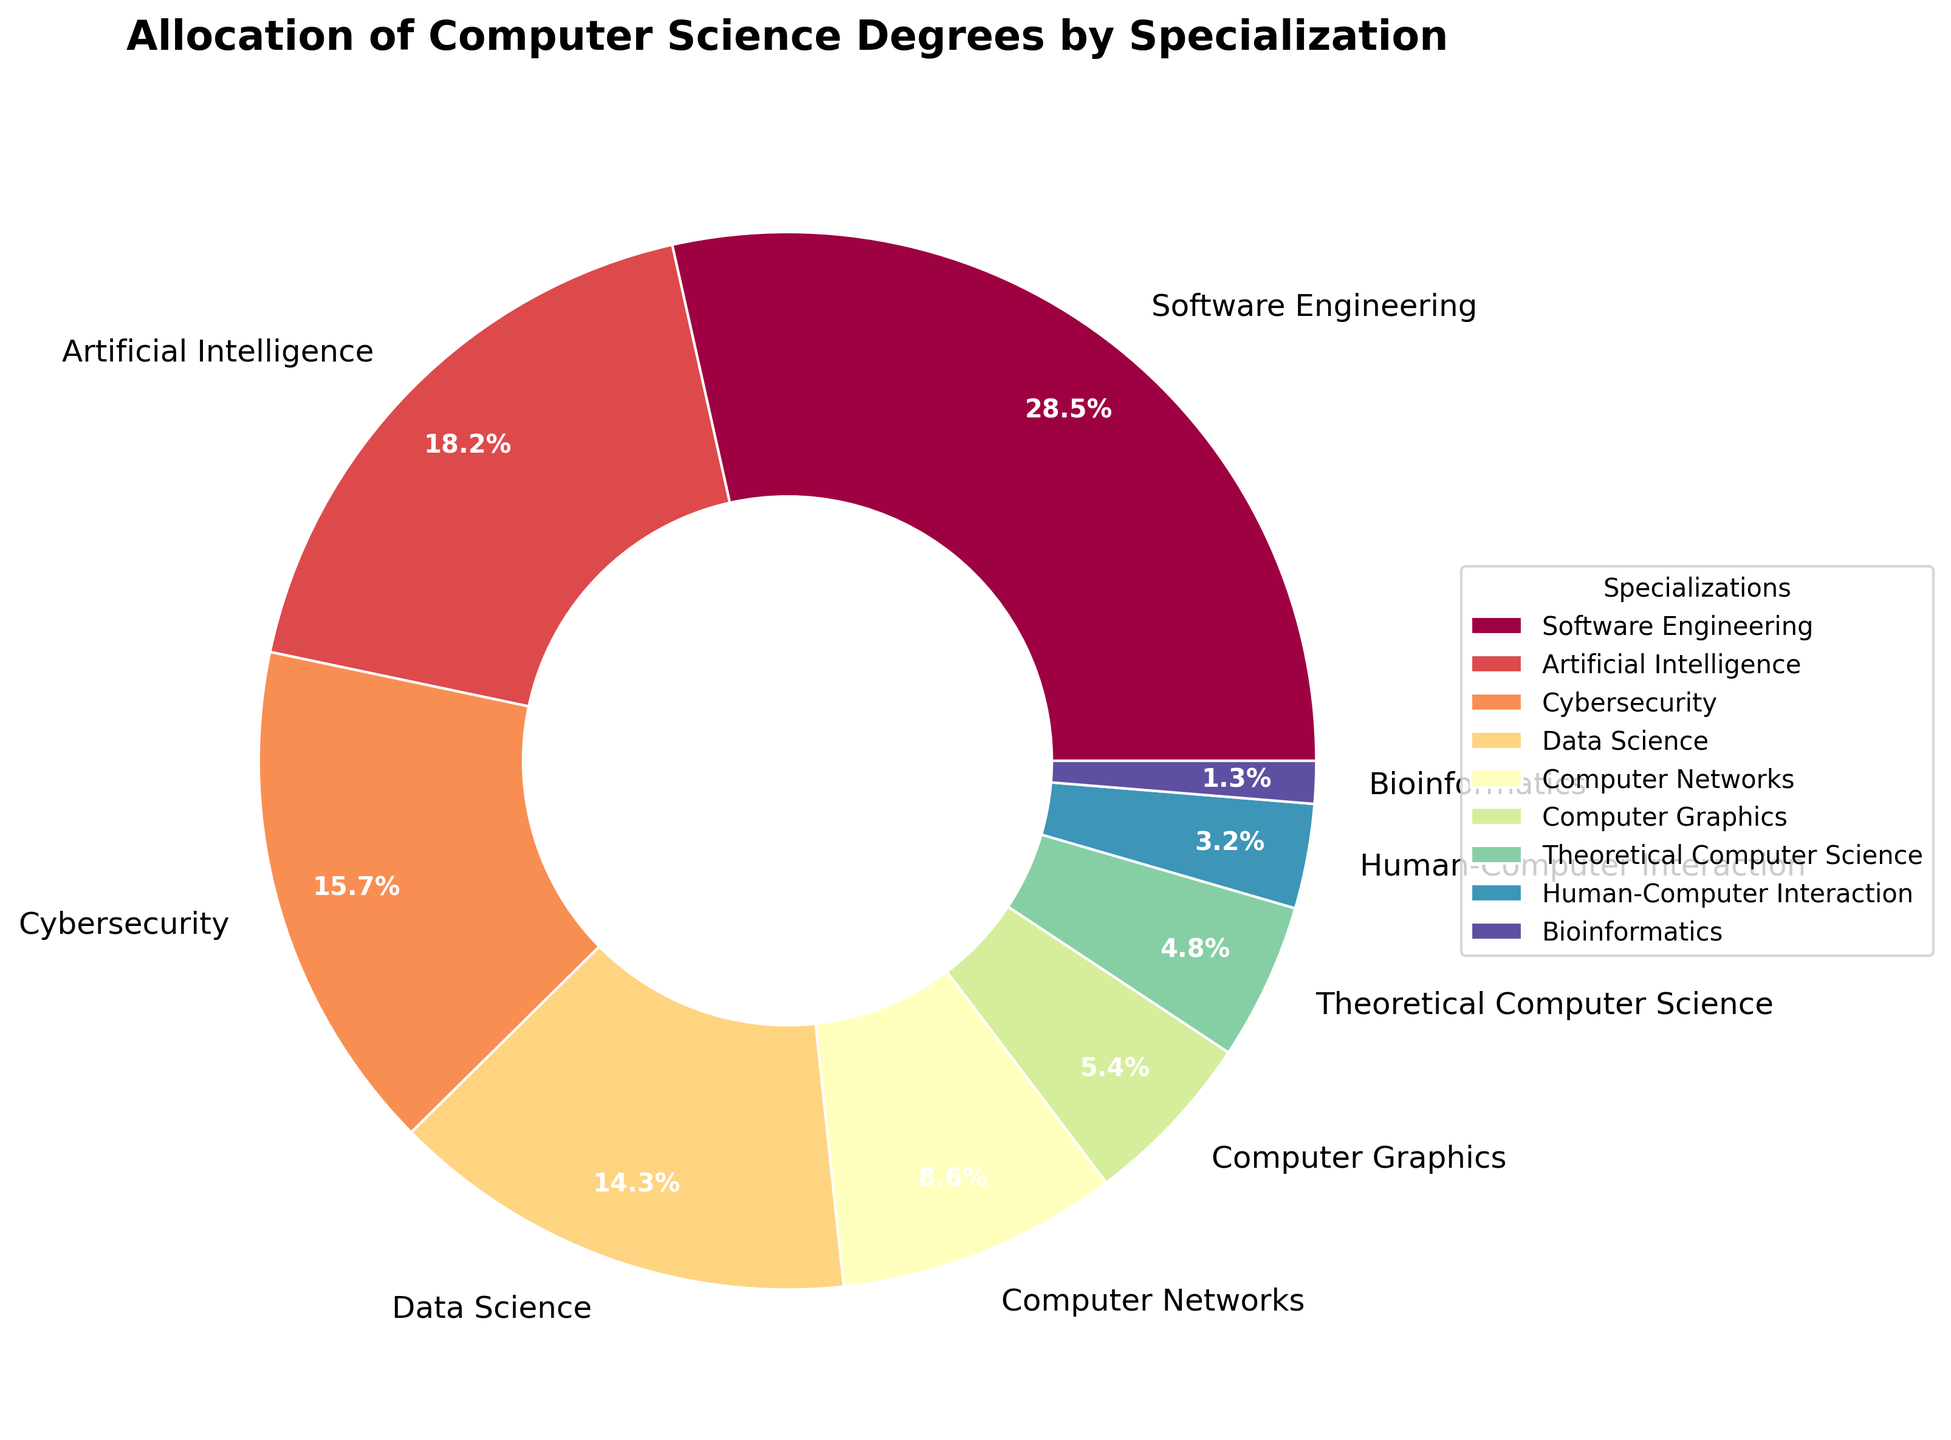Which specialization has the highest percentage of computer science degrees? By observing the sizes of the wedges and reading their labels, we see that Software Engineering has the largest wedge with 28.5%.
Answer: Software Engineering Which specialization has the smallest percentage of computer science degrees? By observing the sizes of the wedges and reading their labels, we see that Bioinformatics has the smallest wedge with 1.3%.
Answer: Bioinformatics What is the combined percentage of degrees in Artificial Intelligence and Cybersecurity? Adding the percentages for Artificial Intelligence (18.2%) and Cybersecurity (15.7%) gives us 18.2% + 15.7% = 33.9%.
Answer: 33.9% How much larger is the percentage of degrees in Software Engineering compared to Data Science? Subtract the percentage of Data Science (14.3%) from the percentage of Software Engineering (28.5%) to find 28.5% - 14.3% = 14.2%.
Answer: 14.2% Which specialization has a higher percentage: Theoretical Computer Science or Human-Computer Interaction? By observing and comparing the labels on the wedges, Theoretical Computer Science has 4.8% while Human-Computer Interaction has 3.2%. Thus, Theoretical Computer Science has a higher percentage.
Answer: Theoretical Computer Science How many specializations have a percentage greater than 10%? Counting the wedges with labels showing percentages greater than 10%: Software Engineering (28.5%), Artificial Intelligence (18.2%), Cybersecurity (15.7%), and Data Science (14.3%), we find there are 4 specializations.
Answer: 4 What is the total percentage of degrees in specializations with percentages less than 10%? Adding the percentages of specializations with less than 10%: Computer Networks (8.6%), Computer Graphics (5.4%), Theoretical Computer Science (4.8%), Human-Computer Interaction (3.2%), and Bioinformatics (1.3%) results in 8.6% + 5.4% + 4.8% + 3.2% + 1.3% = 23.3%.
Answer: 23.3% Which wedge is closest to the center, visually representing a lower percentage value? By observing the wedges, the inner wedges represent lower percentages. The Bioinformatics wedge, at the center with 1.3%, is the closest.
Answer: Bioinformatics Are there more specializations with a percentage higher than 5% or lower than 5%? Counting the specializations with more than 5%: Software Engineering, Artificial Intelligence, Cybersecurity, Data Science, Computer Networks, and Computer Graphics (6). Counting specializations with less than 5%: Theoretical Computer Science, Human-Computer Interaction, and Bioinformatics (3). 6 > 3, so there are more specializations with higher percentages.
Answer: Higher than 5% 